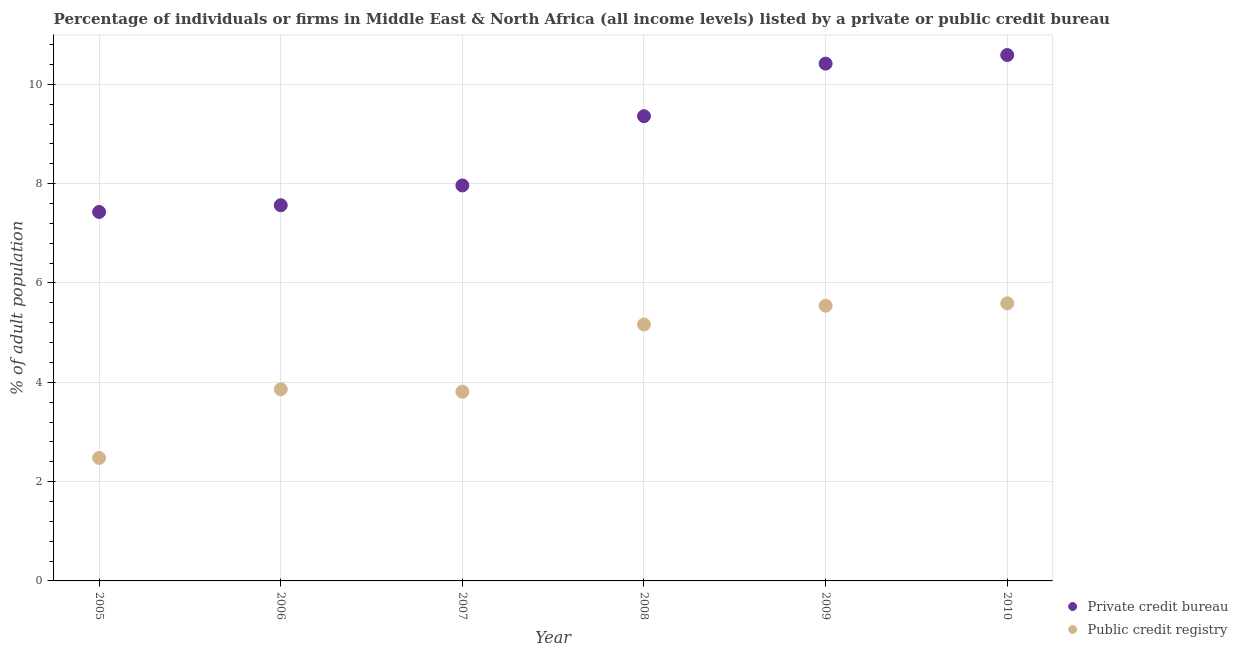How many different coloured dotlines are there?
Offer a very short reply. 2. What is the percentage of firms listed by private credit bureau in 2005?
Make the answer very short. 7.43. Across all years, what is the maximum percentage of firms listed by private credit bureau?
Provide a short and direct response. 10.59. Across all years, what is the minimum percentage of firms listed by private credit bureau?
Your answer should be compact. 7.43. What is the total percentage of firms listed by private credit bureau in the graph?
Ensure brevity in your answer.  53.32. What is the difference between the percentage of firms listed by private credit bureau in 2006 and that in 2008?
Give a very brief answer. -1.79. What is the difference between the percentage of firms listed by public credit bureau in 2007 and the percentage of firms listed by private credit bureau in 2006?
Your response must be concise. -3.75. What is the average percentage of firms listed by private credit bureau per year?
Keep it short and to the point. 8.89. In the year 2008, what is the difference between the percentage of firms listed by private credit bureau and percentage of firms listed by public credit bureau?
Make the answer very short. 4.19. In how many years, is the percentage of firms listed by private credit bureau greater than 4.8 %?
Offer a terse response. 6. What is the ratio of the percentage of firms listed by public credit bureau in 2009 to that in 2010?
Ensure brevity in your answer.  0.99. Is the difference between the percentage of firms listed by public credit bureau in 2007 and 2010 greater than the difference between the percentage of firms listed by private credit bureau in 2007 and 2010?
Provide a succinct answer. Yes. What is the difference between the highest and the second highest percentage of firms listed by private credit bureau?
Your response must be concise. 0.17. What is the difference between the highest and the lowest percentage of firms listed by public credit bureau?
Your response must be concise. 3.11. How many dotlines are there?
Your response must be concise. 2. Are the values on the major ticks of Y-axis written in scientific E-notation?
Offer a very short reply. No. How many legend labels are there?
Provide a succinct answer. 2. What is the title of the graph?
Your response must be concise. Percentage of individuals or firms in Middle East & North Africa (all income levels) listed by a private or public credit bureau. What is the label or title of the X-axis?
Offer a terse response. Year. What is the label or title of the Y-axis?
Your answer should be very brief. % of adult population. What is the % of adult population of Private credit bureau in 2005?
Your response must be concise. 7.43. What is the % of adult population of Public credit registry in 2005?
Your answer should be compact. 2.48. What is the % of adult population in Private credit bureau in 2006?
Offer a terse response. 7.56. What is the % of adult population in Public credit registry in 2006?
Your answer should be very brief. 3.86. What is the % of adult population of Private credit bureau in 2007?
Give a very brief answer. 7.96. What is the % of adult population of Public credit registry in 2007?
Offer a very short reply. 3.81. What is the % of adult population in Private credit bureau in 2008?
Your answer should be very brief. 9.36. What is the % of adult population of Public credit registry in 2008?
Keep it short and to the point. 5.16. What is the % of adult population in Private credit bureau in 2009?
Your response must be concise. 10.42. What is the % of adult population in Public credit registry in 2009?
Your answer should be compact. 5.54. What is the % of adult population of Private credit bureau in 2010?
Give a very brief answer. 10.59. What is the % of adult population in Public credit registry in 2010?
Make the answer very short. 5.59. Across all years, what is the maximum % of adult population of Private credit bureau?
Provide a succinct answer. 10.59. Across all years, what is the maximum % of adult population of Public credit registry?
Your answer should be compact. 5.59. Across all years, what is the minimum % of adult population of Private credit bureau?
Provide a short and direct response. 7.43. Across all years, what is the minimum % of adult population of Public credit registry?
Ensure brevity in your answer.  2.48. What is the total % of adult population in Private credit bureau in the graph?
Offer a very short reply. 53.32. What is the total % of adult population in Public credit registry in the graph?
Your answer should be very brief. 26.44. What is the difference between the % of adult population of Private credit bureau in 2005 and that in 2006?
Keep it short and to the point. -0.14. What is the difference between the % of adult population in Public credit registry in 2005 and that in 2006?
Your answer should be very brief. -1.38. What is the difference between the % of adult population of Private credit bureau in 2005 and that in 2007?
Your answer should be compact. -0.53. What is the difference between the % of adult population in Public credit registry in 2005 and that in 2007?
Your response must be concise. -1.33. What is the difference between the % of adult population in Private credit bureau in 2005 and that in 2008?
Offer a very short reply. -1.93. What is the difference between the % of adult population of Public credit registry in 2005 and that in 2008?
Give a very brief answer. -2.69. What is the difference between the % of adult population in Private credit bureau in 2005 and that in 2009?
Give a very brief answer. -2.99. What is the difference between the % of adult population of Public credit registry in 2005 and that in 2009?
Make the answer very short. -3.07. What is the difference between the % of adult population in Private credit bureau in 2005 and that in 2010?
Give a very brief answer. -3.16. What is the difference between the % of adult population in Public credit registry in 2005 and that in 2010?
Offer a very short reply. -3.11. What is the difference between the % of adult population in Private credit bureau in 2006 and that in 2007?
Your answer should be compact. -0.4. What is the difference between the % of adult population in Public credit registry in 2006 and that in 2007?
Ensure brevity in your answer.  0.05. What is the difference between the % of adult population of Private credit bureau in 2006 and that in 2008?
Offer a very short reply. -1.79. What is the difference between the % of adult population of Public credit registry in 2006 and that in 2008?
Provide a short and direct response. -1.3. What is the difference between the % of adult population of Private credit bureau in 2006 and that in 2009?
Offer a very short reply. -2.85. What is the difference between the % of adult population in Public credit registry in 2006 and that in 2009?
Give a very brief answer. -1.68. What is the difference between the % of adult population in Private credit bureau in 2006 and that in 2010?
Give a very brief answer. -3.02. What is the difference between the % of adult population of Public credit registry in 2006 and that in 2010?
Keep it short and to the point. -1.73. What is the difference between the % of adult population in Private credit bureau in 2007 and that in 2008?
Make the answer very short. -1.39. What is the difference between the % of adult population of Public credit registry in 2007 and that in 2008?
Your response must be concise. -1.35. What is the difference between the % of adult population of Private credit bureau in 2007 and that in 2009?
Offer a terse response. -2.45. What is the difference between the % of adult population of Public credit registry in 2007 and that in 2009?
Your answer should be very brief. -1.73. What is the difference between the % of adult population of Private credit bureau in 2007 and that in 2010?
Provide a short and direct response. -2.63. What is the difference between the % of adult population of Public credit registry in 2007 and that in 2010?
Your response must be concise. -1.78. What is the difference between the % of adult population in Private credit bureau in 2008 and that in 2009?
Keep it short and to the point. -1.06. What is the difference between the % of adult population of Public credit registry in 2008 and that in 2009?
Your response must be concise. -0.38. What is the difference between the % of adult population of Private credit bureau in 2008 and that in 2010?
Your answer should be very brief. -1.23. What is the difference between the % of adult population of Public credit registry in 2008 and that in 2010?
Give a very brief answer. -0.43. What is the difference between the % of adult population of Private credit bureau in 2009 and that in 2010?
Ensure brevity in your answer.  -0.17. What is the difference between the % of adult population of Public credit registry in 2009 and that in 2010?
Ensure brevity in your answer.  -0.05. What is the difference between the % of adult population in Private credit bureau in 2005 and the % of adult population in Public credit registry in 2006?
Your answer should be compact. 3.57. What is the difference between the % of adult population of Private credit bureau in 2005 and the % of adult population of Public credit registry in 2007?
Provide a short and direct response. 3.62. What is the difference between the % of adult population in Private credit bureau in 2005 and the % of adult population in Public credit registry in 2008?
Provide a short and direct response. 2.27. What is the difference between the % of adult population of Private credit bureau in 2005 and the % of adult population of Public credit registry in 2009?
Your answer should be compact. 1.89. What is the difference between the % of adult population in Private credit bureau in 2005 and the % of adult population in Public credit registry in 2010?
Make the answer very short. 1.84. What is the difference between the % of adult population of Private credit bureau in 2006 and the % of adult population of Public credit registry in 2007?
Keep it short and to the point. 3.75. What is the difference between the % of adult population of Private credit bureau in 2006 and the % of adult population of Public credit registry in 2008?
Give a very brief answer. 2.4. What is the difference between the % of adult population in Private credit bureau in 2006 and the % of adult population in Public credit registry in 2009?
Make the answer very short. 2.02. What is the difference between the % of adult population of Private credit bureau in 2006 and the % of adult population of Public credit registry in 2010?
Your answer should be compact. 1.98. What is the difference between the % of adult population of Private credit bureau in 2007 and the % of adult population of Public credit registry in 2008?
Your answer should be very brief. 2.8. What is the difference between the % of adult population of Private credit bureau in 2007 and the % of adult population of Public credit registry in 2009?
Keep it short and to the point. 2.42. What is the difference between the % of adult population in Private credit bureau in 2007 and the % of adult population in Public credit registry in 2010?
Provide a short and direct response. 2.37. What is the difference between the % of adult population of Private credit bureau in 2008 and the % of adult population of Public credit registry in 2009?
Your answer should be very brief. 3.82. What is the difference between the % of adult population in Private credit bureau in 2008 and the % of adult population in Public credit registry in 2010?
Offer a terse response. 3.77. What is the difference between the % of adult population of Private credit bureau in 2009 and the % of adult population of Public credit registry in 2010?
Keep it short and to the point. 4.83. What is the average % of adult population in Private credit bureau per year?
Provide a succinct answer. 8.89. What is the average % of adult population of Public credit registry per year?
Your answer should be very brief. 4.41. In the year 2005, what is the difference between the % of adult population in Private credit bureau and % of adult population in Public credit registry?
Give a very brief answer. 4.95. In the year 2006, what is the difference between the % of adult population in Private credit bureau and % of adult population in Public credit registry?
Ensure brevity in your answer.  3.71. In the year 2007, what is the difference between the % of adult population in Private credit bureau and % of adult population in Public credit registry?
Your answer should be compact. 4.15. In the year 2008, what is the difference between the % of adult population in Private credit bureau and % of adult population in Public credit registry?
Your answer should be very brief. 4.19. In the year 2009, what is the difference between the % of adult population of Private credit bureau and % of adult population of Public credit registry?
Your response must be concise. 4.87. In the year 2010, what is the difference between the % of adult population in Private credit bureau and % of adult population in Public credit registry?
Ensure brevity in your answer.  5. What is the ratio of the % of adult population of Private credit bureau in 2005 to that in 2006?
Offer a very short reply. 0.98. What is the ratio of the % of adult population of Public credit registry in 2005 to that in 2006?
Make the answer very short. 0.64. What is the ratio of the % of adult population in Private credit bureau in 2005 to that in 2007?
Offer a terse response. 0.93. What is the ratio of the % of adult population in Public credit registry in 2005 to that in 2007?
Your answer should be very brief. 0.65. What is the ratio of the % of adult population in Private credit bureau in 2005 to that in 2008?
Give a very brief answer. 0.79. What is the ratio of the % of adult population of Public credit registry in 2005 to that in 2008?
Make the answer very short. 0.48. What is the ratio of the % of adult population in Private credit bureau in 2005 to that in 2009?
Your answer should be very brief. 0.71. What is the ratio of the % of adult population in Public credit registry in 2005 to that in 2009?
Offer a terse response. 0.45. What is the ratio of the % of adult population of Private credit bureau in 2005 to that in 2010?
Provide a succinct answer. 0.7. What is the ratio of the % of adult population in Public credit registry in 2005 to that in 2010?
Your answer should be very brief. 0.44. What is the ratio of the % of adult population in Public credit registry in 2006 to that in 2007?
Give a very brief answer. 1.01. What is the ratio of the % of adult population of Private credit bureau in 2006 to that in 2008?
Offer a terse response. 0.81. What is the ratio of the % of adult population in Public credit registry in 2006 to that in 2008?
Provide a succinct answer. 0.75. What is the ratio of the % of adult population in Private credit bureau in 2006 to that in 2009?
Keep it short and to the point. 0.73. What is the ratio of the % of adult population of Public credit registry in 2006 to that in 2009?
Provide a short and direct response. 0.7. What is the ratio of the % of adult population of Private credit bureau in 2006 to that in 2010?
Provide a succinct answer. 0.71. What is the ratio of the % of adult population in Public credit registry in 2006 to that in 2010?
Keep it short and to the point. 0.69. What is the ratio of the % of adult population of Private credit bureau in 2007 to that in 2008?
Your response must be concise. 0.85. What is the ratio of the % of adult population of Public credit registry in 2007 to that in 2008?
Keep it short and to the point. 0.74. What is the ratio of the % of adult population in Private credit bureau in 2007 to that in 2009?
Keep it short and to the point. 0.76. What is the ratio of the % of adult population in Public credit registry in 2007 to that in 2009?
Give a very brief answer. 0.69. What is the ratio of the % of adult population in Private credit bureau in 2007 to that in 2010?
Offer a very short reply. 0.75. What is the ratio of the % of adult population of Public credit registry in 2007 to that in 2010?
Your answer should be very brief. 0.68. What is the ratio of the % of adult population in Private credit bureau in 2008 to that in 2009?
Ensure brevity in your answer.  0.9. What is the ratio of the % of adult population of Public credit registry in 2008 to that in 2009?
Provide a succinct answer. 0.93. What is the ratio of the % of adult population of Private credit bureau in 2008 to that in 2010?
Your answer should be very brief. 0.88. What is the ratio of the % of adult population in Public credit registry in 2008 to that in 2010?
Your response must be concise. 0.92. What is the ratio of the % of adult population of Private credit bureau in 2009 to that in 2010?
Offer a terse response. 0.98. What is the ratio of the % of adult population of Public credit registry in 2009 to that in 2010?
Your answer should be very brief. 0.99. What is the difference between the highest and the second highest % of adult population in Private credit bureau?
Make the answer very short. 0.17. What is the difference between the highest and the second highest % of adult population in Public credit registry?
Your answer should be compact. 0.05. What is the difference between the highest and the lowest % of adult population of Private credit bureau?
Ensure brevity in your answer.  3.16. What is the difference between the highest and the lowest % of adult population in Public credit registry?
Offer a terse response. 3.11. 